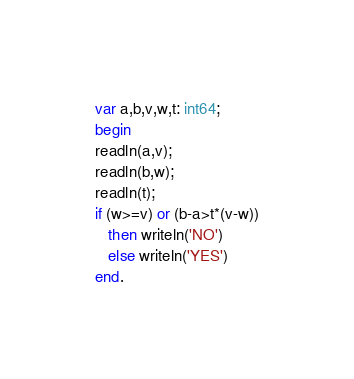Convert code to text. <code><loc_0><loc_0><loc_500><loc_500><_Pascal_>var a,b,v,w,t: int64;
begin
readln(a,v);
readln(b,w);
readln(t);
if (w>=v) or (b-a>t*(v-w))
   then writeln('NO')
   else writeln('YES')
end.
</code> 